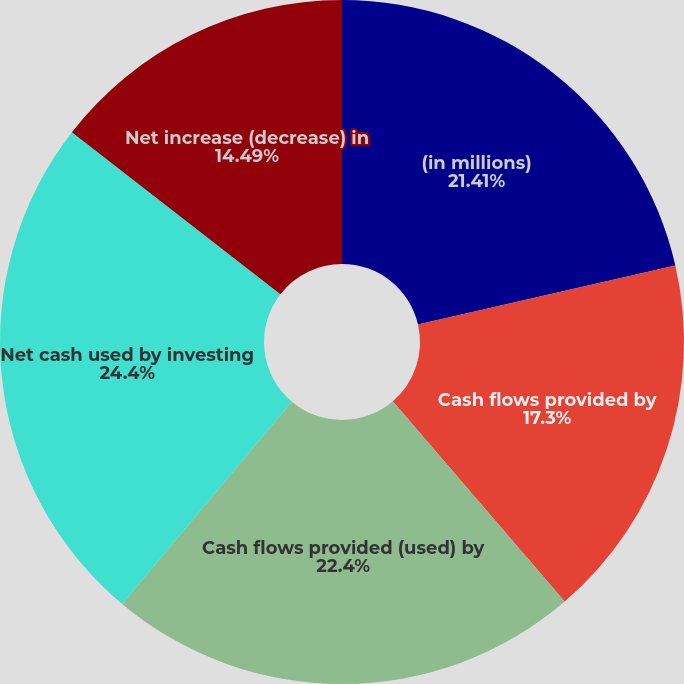Convert chart. <chart><loc_0><loc_0><loc_500><loc_500><pie_chart><fcel>(in millions)<fcel>Cash flows provided by<fcel>Cash flows provided (used) by<fcel>Net cash used by investing<fcel>Net increase (decrease) in<nl><fcel>21.41%<fcel>17.3%<fcel>22.4%<fcel>24.39%<fcel>14.49%<nl></chart> 